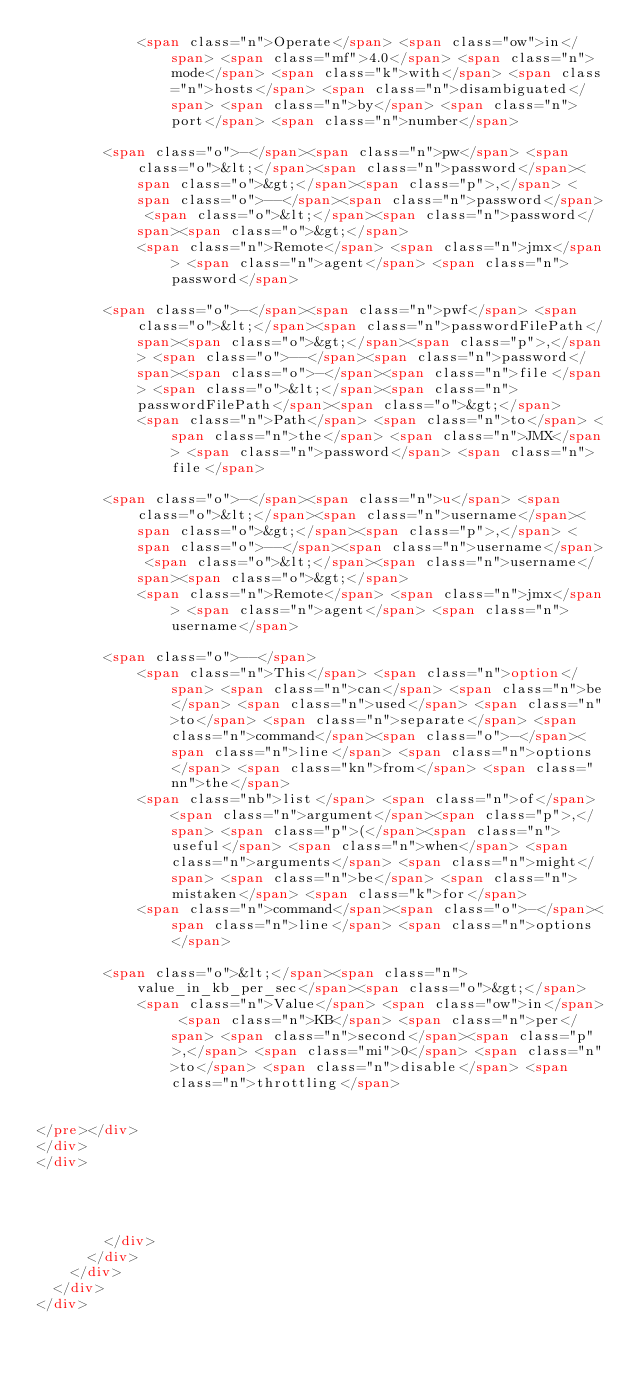<code> <loc_0><loc_0><loc_500><loc_500><_HTML_>            <span class="n">Operate</span> <span class="ow">in</span> <span class="mf">4.0</span> <span class="n">mode</span> <span class="k">with</span> <span class="n">hosts</span> <span class="n">disambiguated</span> <span class="n">by</span> <span class="n">port</span> <span class="n">number</span>

        <span class="o">-</span><span class="n">pw</span> <span class="o">&lt;</span><span class="n">password</span><span class="o">&gt;</span><span class="p">,</span> <span class="o">--</span><span class="n">password</span> <span class="o">&lt;</span><span class="n">password</span><span class="o">&gt;</span>
            <span class="n">Remote</span> <span class="n">jmx</span> <span class="n">agent</span> <span class="n">password</span>

        <span class="o">-</span><span class="n">pwf</span> <span class="o">&lt;</span><span class="n">passwordFilePath</span><span class="o">&gt;</span><span class="p">,</span> <span class="o">--</span><span class="n">password</span><span class="o">-</span><span class="n">file</span> <span class="o">&lt;</span><span class="n">passwordFilePath</span><span class="o">&gt;</span>
            <span class="n">Path</span> <span class="n">to</span> <span class="n">the</span> <span class="n">JMX</span> <span class="n">password</span> <span class="n">file</span>

        <span class="o">-</span><span class="n">u</span> <span class="o">&lt;</span><span class="n">username</span><span class="o">&gt;</span><span class="p">,</span> <span class="o">--</span><span class="n">username</span> <span class="o">&lt;</span><span class="n">username</span><span class="o">&gt;</span>
            <span class="n">Remote</span> <span class="n">jmx</span> <span class="n">agent</span> <span class="n">username</span>

        <span class="o">--</span>
            <span class="n">This</span> <span class="n">option</span> <span class="n">can</span> <span class="n">be</span> <span class="n">used</span> <span class="n">to</span> <span class="n">separate</span> <span class="n">command</span><span class="o">-</span><span class="n">line</span> <span class="n">options</span> <span class="kn">from</span> <span class="nn">the</span>
            <span class="nb">list</span> <span class="n">of</span> <span class="n">argument</span><span class="p">,</span> <span class="p">(</span><span class="n">useful</span> <span class="n">when</span> <span class="n">arguments</span> <span class="n">might</span> <span class="n">be</span> <span class="n">mistaken</span> <span class="k">for</span>
            <span class="n">command</span><span class="o">-</span><span class="n">line</span> <span class="n">options</span>

        <span class="o">&lt;</span><span class="n">value_in_kb_per_sec</span><span class="o">&gt;</span>
            <span class="n">Value</span> <span class="ow">in</span> <span class="n">KB</span> <span class="n">per</span> <span class="n">second</span><span class="p">,</span> <span class="mi">0</span> <span class="n">to</span> <span class="n">disable</span> <span class="n">throttling</span>


</pre></div>
</div>
</div>



          
        </div>
      </div>
    </div>
  </div>
</div></code> 